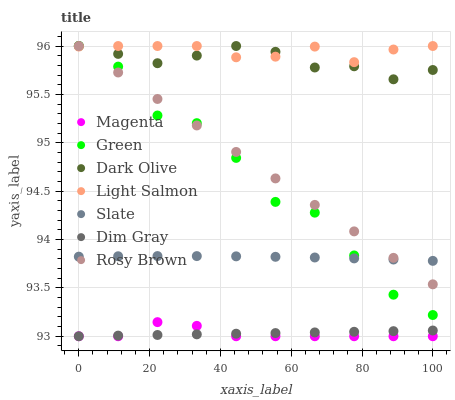Does Magenta have the minimum area under the curve?
Answer yes or no. Yes. Does Light Salmon have the maximum area under the curve?
Answer yes or no. Yes. Does Dim Gray have the minimum area under the curve?
Answer yes or no. No. Does Dim Gray have the maximum area under the curve?
Answer yes or no. No. Is Dim Gray the smoothest?
Answer yes or no. Yes. Is Green the roughest?
Answer yes or no. Yes. Is Slate the smoothest?
Answer yes or no. No. Is Slate the roughest?
Answer yes or no. No. Does Dim Gray have the lowest value?
Answer yes or no. Yes. Does Slate have the lowest value?
Answer yes or no. No. Does Rosy Brown have the highest value?
Answer yes or no. Yes. Does Slate have the highest value?
Answer yes or no. No. Is Dim Gray less than Green?
Answer yes or no. Yes. Is Dark Olive greater than Magenta?
Answer yes or no. Yes. Does Green intersect Dark Olive?
Answer yes or no. Yes. Is Green less than Dark Olive?
Answer yes or no. No. Is Green greater than Dark Olive?
Answer yes or no. No. Does Dim Gray intersect Green?
Answer yes or no. No. 